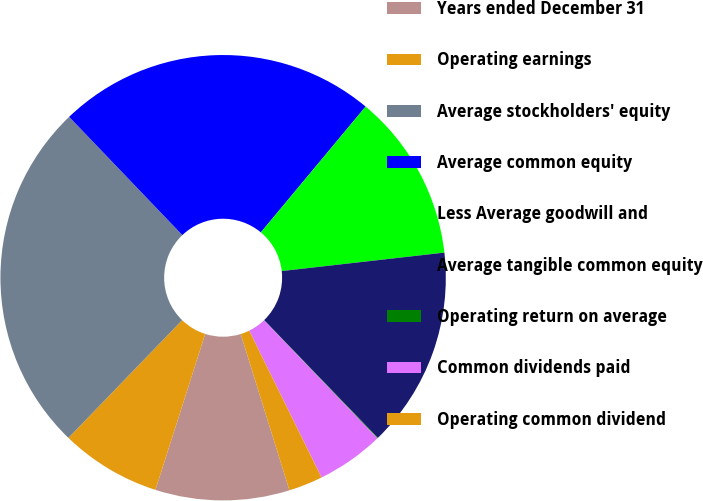Convert chart to OTSL. <chart><loc_0><loc_0><loc_500><loc_500><pie_chart><fcel>Years ended December 31<fcel>Operating earnings<fcel>Average stockholders' equity<fcel>Average common equity<fcel>Less Average goodwill and<fcel>Average tangible common equity<fcel>Operating return on average<fcel>Common dividends paid<fcel>Operating common dividend<nl><fcel>9.73%<fcel>7.31%<fcel>25.62%<fcel>23.2%<fcel>12.15%<fcel>14.57%<fcel>0.05%<fcel>4.89%<fcel>2.47%<nl></chart> 